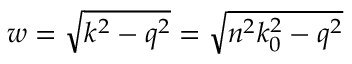<formula> <loc_0><loc_0><loc_500><loc_500>w = \sqrt { k ^ { 2 } - q ^ { 2 } } = \sqrt { n ^ { 2 } k _ { 0 } ^ { 2 } - q ^ { 2 } }</formula> 